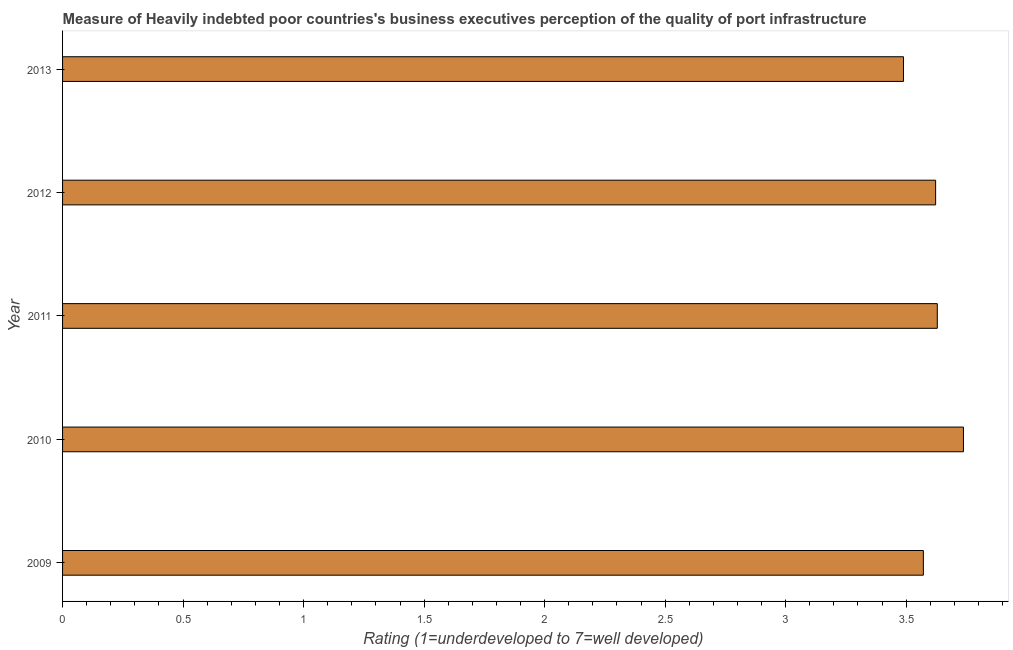Does the graph contain any zero values?
Your response must be concise. No. What is the title of the graph?
Provide a succinct answer. Measure of Heavily indebted poor countries's business executives perception of the quality of port infrastructure. What is the label or title of the X-axis?
Offer a very short reply. Rating (1=underdeveloped to 7=well developed) . What is the label or title of the Y-axis?
Your response must be concise. Year. What is the rating measuring quality of port infrastructure in 2011?
Offer a very short reply. 3.63. Across all years, what is the maximum rating measuring quality of port infrastructure?
Ensure brevity in your answer.  3.74. Across all years, what is the minimum rating measuring quality of port infrastructure?
Offer a very short reply. 3.49. What is the sum of the rating measuring quality of port infrastructure?
Give a very brief answer. 18.05. What is the difference between the rating measuring quality of port infrastructure in 2010 and 2013?
Your answer should be compact. 0.25. What is the average rating measuring quality of port infrastructure per year?
Your answer should be compact. 3.61. What is the median rating measuring quality of port infrastructure?
Ensure brevity in your answer.  3.62. In how many years, is the rating measuring quality of port infrastructure greater than 0.6 ?
Your answer should be very brief. 5. Do a majority of the years between 2009 and 2013 (inclusive) have rating measuring quality of port infrastructure greater than 1.7 ?
Keep it short and to the point. Yes. What is the ratio of the rating measuring quality of port infrastructure in 2010 to that in 2013?
Your response must be concise. 1.07. Is the rating measuring quality of port infrastructure in 2011 less than that in 2013?
Keep it short and to the point. No. Is the difference between the rating measuring quality of port infrastructure in 2009 and 2011 greater than the difference between any two years?
Provide a short and direct response. No. What is the difference between the highest and the second highest rating measuring quality of port infrastructure?
Ensure brevity in your answer.  0.11. What is the difference between the highest and the lowest rating measuring quality of port infrastructure?
Your response must be concise. 0.25. How many bars are there?
Offer a terse response. 5. What is the difference between two consecutive major ticks on the X-axis?
Give a very brief answer. 0.5. What is the Rating (1=underdeveloped to 7=well developed)  in 2009?
Keep it short and to the point. 3.57. What is the Rating (1=underdeveloped to 7=well developed)  in 2010?
Your answer should be compact. 3.74. What is the Rating (1=underdeveloped to 7=well developed)  in 2011?
Provide a succinct answer. 3.63. What is the Rating (1=underdeveloped to 7=well developed)  of 2012?
Provide a short and direct response. 3.62. What is the Rating (1=underdeveloped to 7=well developed)  in 2013?
Your answer should be very brief. 3.49. What is the difference between the Rating (1=underdeveloped to 7=well developed)  in 2009 and 2010?
Your response must be concise. -0.17. What is the difference between the Rating (1=underdeveloped to 7=well developed)  in 2009 and 2011?
Provide a succinct answer. -0.06. What is the difference between the Rating (1=underdeveloped to 7=well developed)  in 2009 and 2012?
Keep it short and to the point. -0.05. What is the difference between the Rating (1=underdeveloped to 7=well developed)  in 2009 and 2013?
Ensure brevity in your answer.  0.08. What is the difference between the Rating (1=underdeveloped to 7=well developed)  in 2010 and 2011?
Your response must be concise. 0.11. What is the difference between the Rating (1=underdeveloped to 7=well developed)  in 2010 and 2012?
Your answer should be compact. 0.12. What is the difference between the Rating (1=underdeveloped to 7=well developed)  in 2010 and 2013?
Make the answer very short. 0.25. What is the difference between the Rating (1=underdeveloped to 7=well developed)  in 2011 and 2012?
Offer a terse response. 0.01. What is the difference between the Rating (1=underdeveloped to 7=well developed)  in 2011 and 2013?
Your answer should be very brief. 0.14. What is the difference between the Rating (1=underdeveloped to 7=well developed)  in 2012 and 2013?
Offer a terse response. 0.13. What is the ratio of the Rating (1=underdeveloped to 7=well developed)  in 2009 to that in 2010?
Make the answer very short. 0.96. What is the ratio of the Rating (1=underdeveloped to 7=well developed)  in 2009 to that in 2012?
Your answer should be very brief. 0.99. What is the ratio of the Rating (1=underdeveloped to 7=well developed)  in 2009 to that in 2013?
Ensure brevity in your answer.  1.02. What is the ratio of the Rating (1=underdeveloped to 7=well developed)  in 2010 to that in 2012?
Ensure brevity in your answer.  1.03. What is the ratio of the Rating (1=underdeveloped to 7=well developed)  in 2010 to that in 2013?
Your answer should be compact. 1.07. What is the ratio of the Rating (1=underdeveloped to 7=well developed)  in 2012 to that in 2013?
Provide a short and direct response. 1.04. 